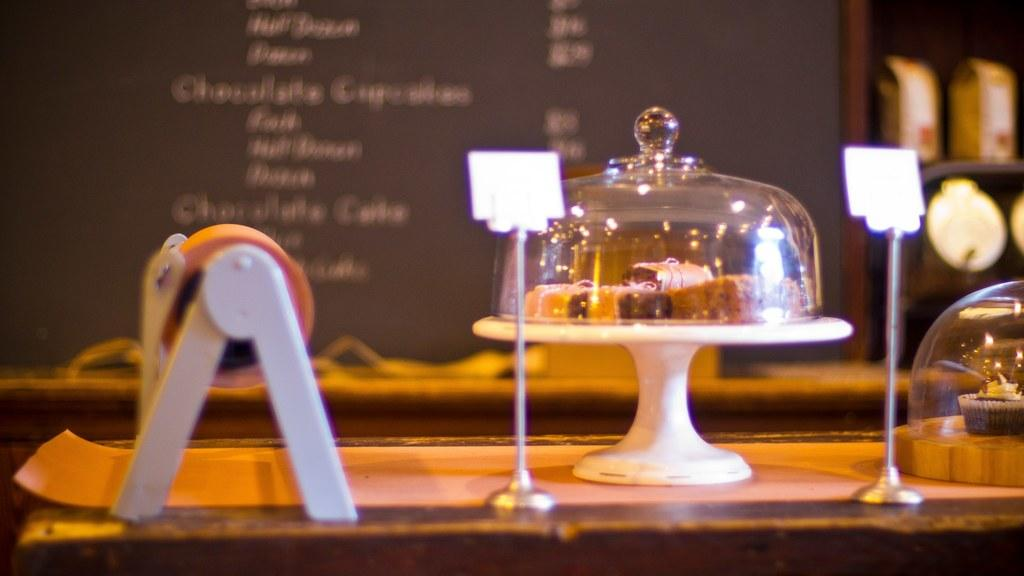What is the main object in the middle of the image? There is a lid made up of glass in the middle of the image. What is under the glass lid? There are food items under the glass lid. What can be seen at the back side of the image? There is a board of menu at the back side of the image. Can you see a nose on any of the food items in the image? There are no noses present on the food items in the image. Is there a market visible in the image? There is no market visible in the image; it features a glass lid with food items and a menu board. 